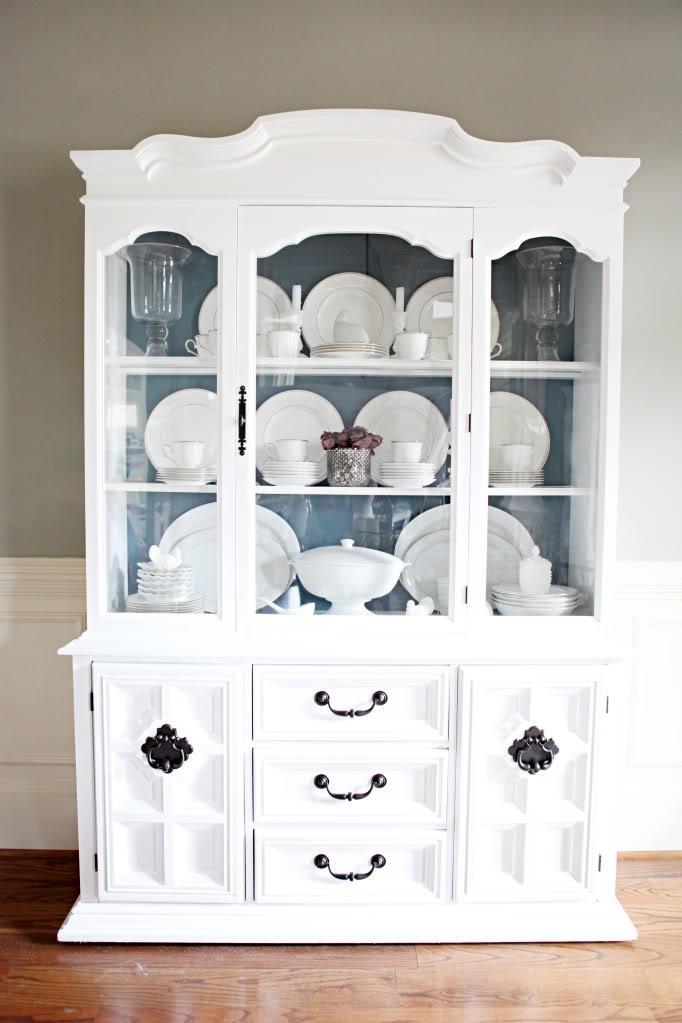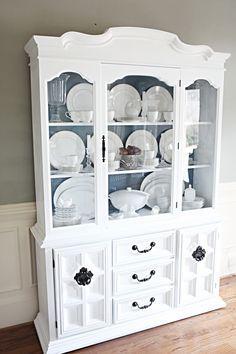The first image is the image on the left, the second image is the image on the right. Given the left and right images, does the statement "At least one cabinet has a non-flat top with nothing perched above it, and a bottom that lacks any scrollwork." hold true? Answer yes or no. Yes. The first image is the image on the left, the second image is the image on the right. Assess this claim about the two images: "Within the china cabinet, one of the cabinet's inner walls have been painted green, but not blue.". Correct or not? Answer yes or no. No. 